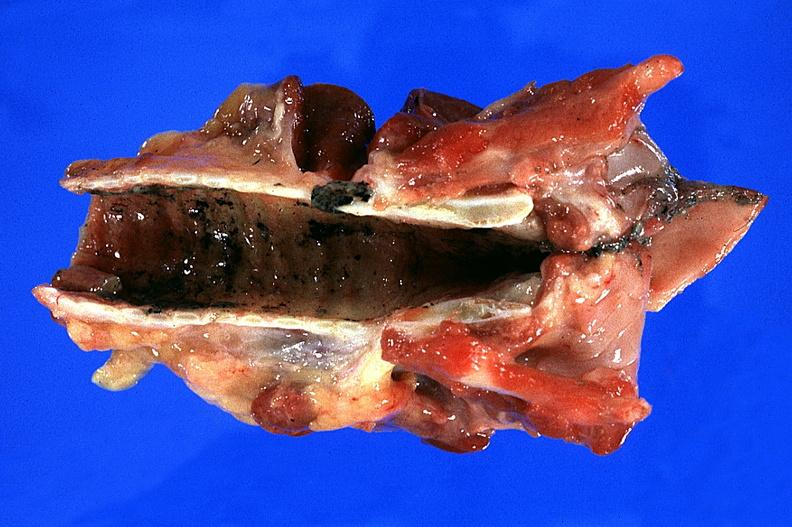s oil acid present?
Answer the question using a single word or phrase. No 